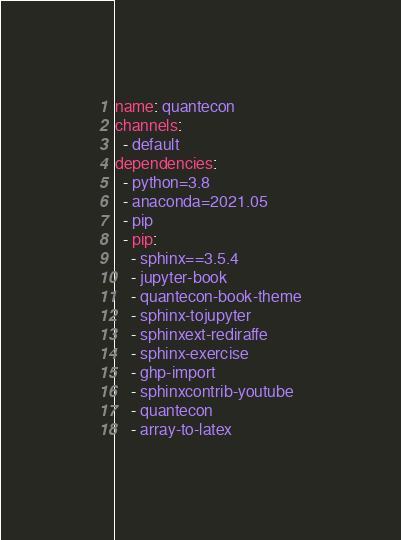Convert code to text. <code><loc_0><loc_0><loc_500><loc_500><_YAML_>name: quantecon
channels:
  - default
dependencies:
  - python=3.8
  - anaconda=2021.05
  - pip
  - pip:
    - sphinx==3.5.4
    - jupyter-book
    - quantecon-book-theme
    - sphinx-tojupyter
    - sphinxext-rediraffe
    - sphinx-exercise
    - ghp-import
    - sphinxcontrib-youtube
    - quantecon
    - array-to-latex


</code> 